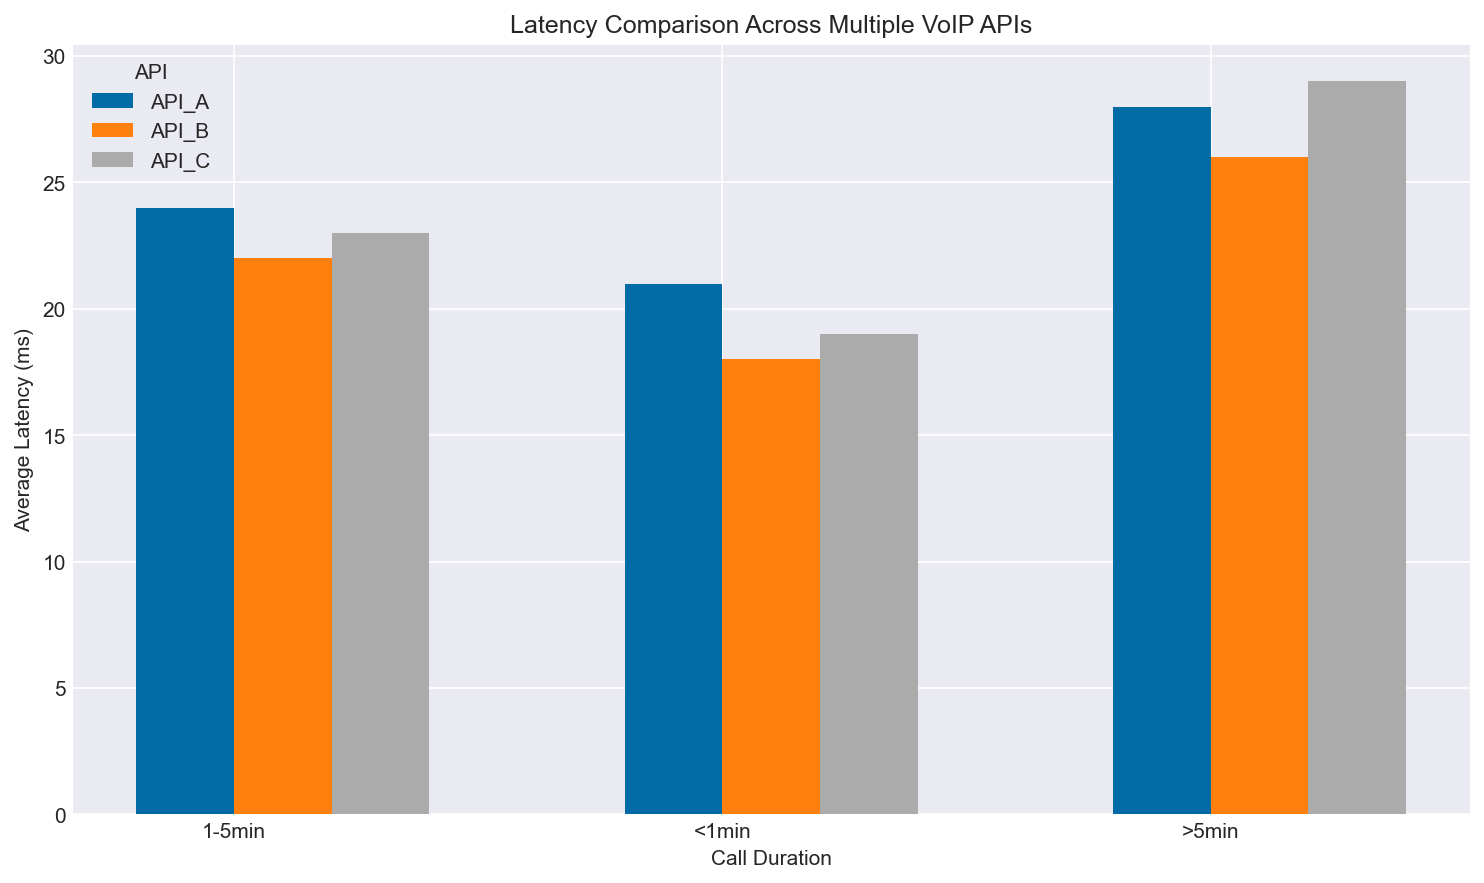Which API has the lowest average latency for call durations <1min? To determine the API with the lowest average latency for call durations <1min, I look at the bars corresponding to the <1min duration. I compare the heights of the bars for API_A, API_B, and API_C. The shortest bar corresponds to API_B.
Answer: API_B Which API shows the highest average latency for call durations >5min? To find the API with the highest latency for >5min calls, I compare the height of the bars for API_A, API_B, and API_C in the >5min category. The tallest bar corresponds to API_C.
Answer: API_C How does the latency for API_A change from call durations <1min to 1-5min? To observe the change in latency for API_A, I look at the average latency bars for API_A in the <1min and 1-5min categories. The bars indicate a slight increase in latency from <1min to 1-5min for API_A.
Answer: Slight increase Compare the average latency between API_A and API_C for 1-5min call durations. To compare the average latency, I examine the bars representing API_A and API_C in the 1-5min duration category. API_A has a slightly lower bar (around 24ms) compared to API_C (around 23ms), indicating API_A has a higher average latency than API_C for 1-5min call durations.
Answer: API_A has higher latency Which call duration category shows the smallest difference in average latency among the APIs? To find the category with the smallest difference, I observe the bars for each call duration category (<1min, 1-5min, >5min). The <1min category shows bars that are the closest in height, indicating the smallest difference in average latency among the APIs.
Answer: <1min Rank the APIs in descending order of average latency for call durations 1-5min. I compare the heights of the bars for the 1-5min call duration. By visual inspection, the bars for API_A, API_B, and API_C are nearly equal but have slight differences: API_B (21-23ms), API_C (22-24ms), and API_A (23-25ms). The descending order is API_A, API_C, and API_B.
Answer: API_A, API_C, API_B What is the average latency difference between the longest and shortest call durations for API_B? For API_B, check the average latency at <1min and >5min. The average latency values for API_B in <1min and >5min categories are approximately 18ms and 26ms respectively. The difference is 26 - 18 = 8ms.
Answer: 8ms Which API has the most consistent average latency across different call durations? To determine consistency, I observe the variation in the bar heights for each API. The smaller the range of variation, the more consistent the API is. API_B shows the least variation in the heights of its bars across all call durations.
Answer: API_B Is there any API whose average latency for calls longer than 5 minutes is less than the average latency for calls between 1-5 minutes for other APIs? I compare the bar heights for the >5min category with the 1-5min category of other APIs. All >5min latencies are higher than the 1-5min latencies of any API.
Answer: No For call durations >5min, by how much is API_C's average latency higher than API_B's average latency? For the >5min duration, find the average latency of API_C and API_B by referencing the bar heights. API_C's latency is about 29ms while API_B's is 26ms. The difference is 29 - 26 = 3ms.
Answer: 3ms 